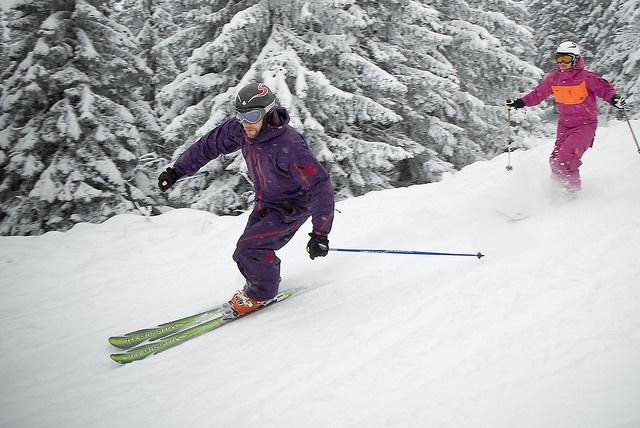Describe the objects in this image and their specific colors. I can see people in darkgray, black, purple, and gray tones, people in darkgray, purple, and lightgray tones, skis in darkgray, gray, and olive tones, and skis in lightgray and darkgray tones in this image. 